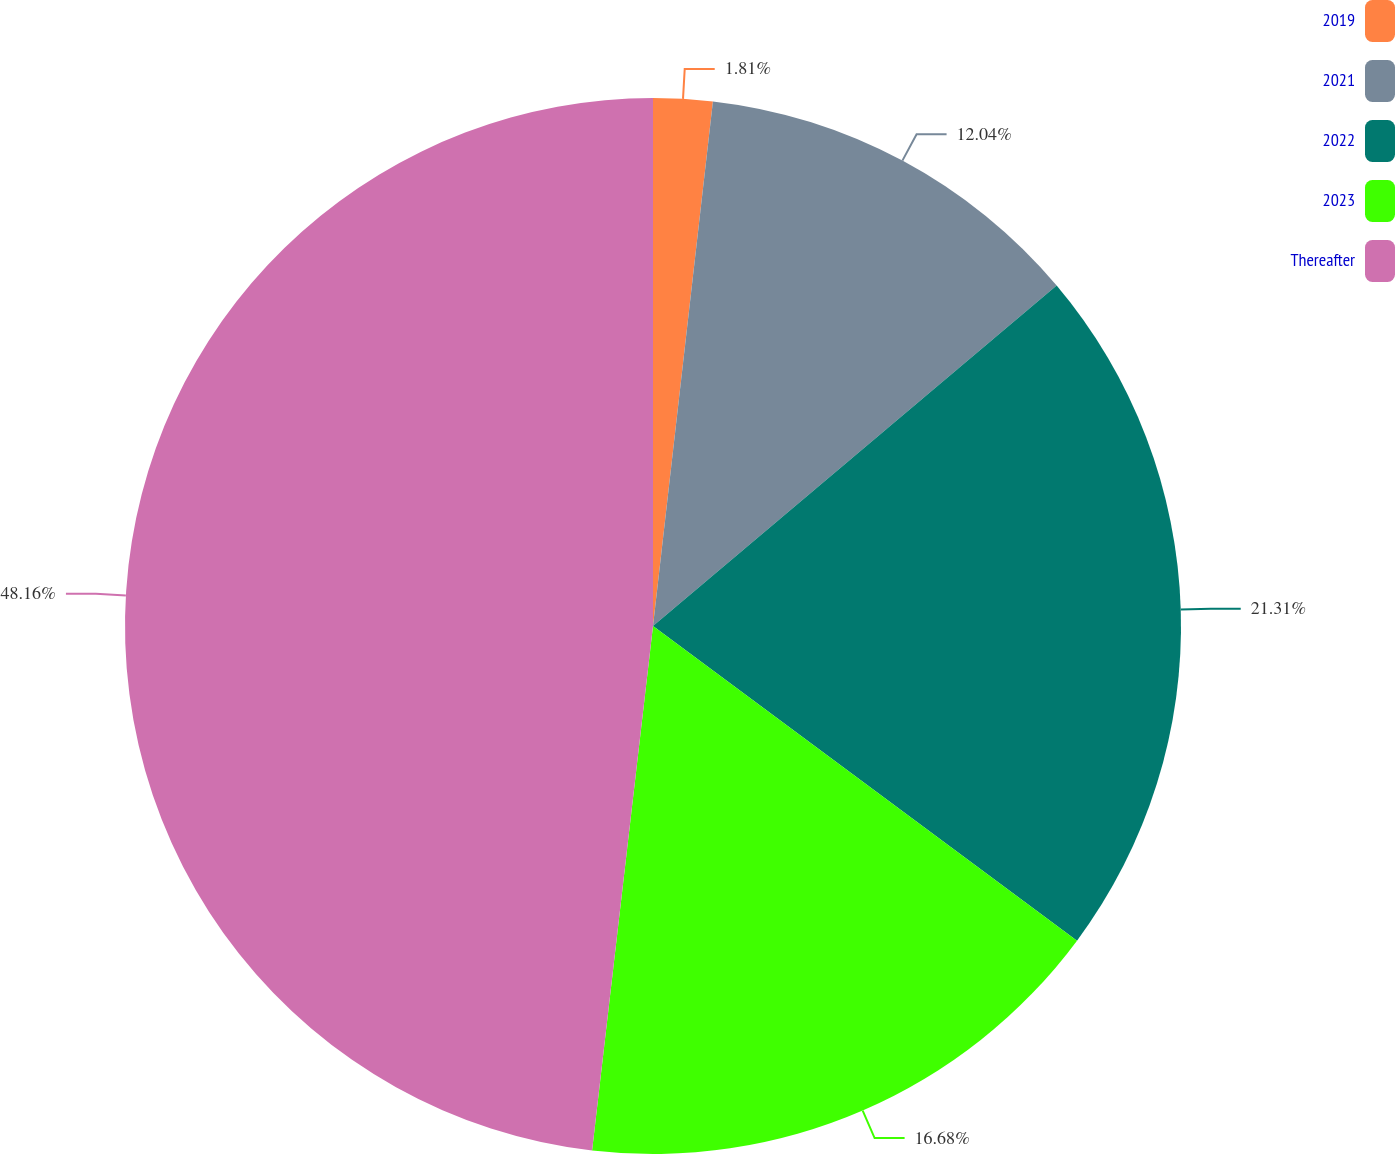Convert chart. <chart><loc_0><loc_0><loc_500><loc_500><pie_chart><fcel>2019<fcel>2021<fcel>2022<fcel>2023<fcel>Thereafter<nl><fcel>1.81%<fcel>12.04%<fcel>21.31%<fcel>16.68%<fcel>48.16%<nl></chart> 